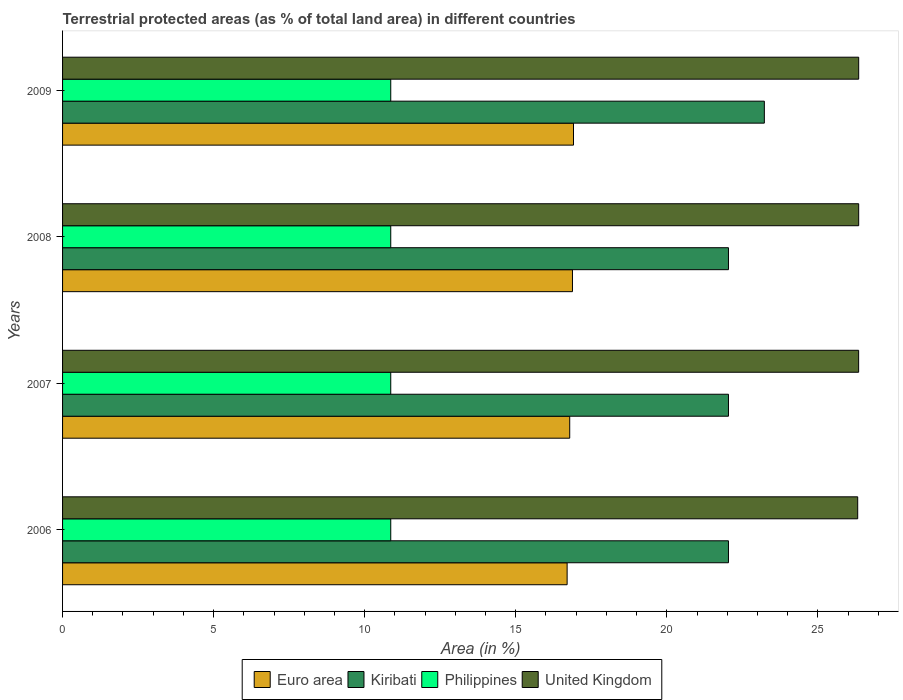Are the number of bars on each tick of the Y-axis equal?
Provide a short and direct response. Yes. How many bars are there on the 3rd tick from the top?
Offer a very short reply. 4. What is the label of the 1st group of bars from the top?
Your answer should be compact. 2009. What is the percentage of terrestrial protected land in Euro area in 2009?
Your response must be concise. 16.91. Across all years, what is the maximum percentage of terrestrial protected land in Philippines?
Your answer should be very brief. 10.86. Across all years, what is the minimum percentage of terrestrial protected land in Euro area?
Ensure brevity in your answer.  16.7. In which year was the percentage of terrestrial protected land in United Kingdom maximum?
Offer a very short reply. 2009. What is the total percentage of terrestrial protected land in Euro area in the graph?
Offer a terse response. 67.28. What is the difference between the percentage of terrestrial protected land in United Kingdom in 2007 and that in 2009?
Your response must be concise. -0. What is the difference between the percentage of terrestrial protected land in Euro area in 2009 and the percentage of terrestrial protected land in Philippines in 2008?
Your answer should be compact. 6.05. What is the average percentage of terrestrial protected land in Kiribati per year?
Give a very brief answer. 22.34. In the year 2006, what is the difference between the percentage of terrestrial protected land in United Kingdom and percentage of terrestrial protected land in Kiribati?
Ensure brevity in your answer.  4.28. In how many years, is the percentage of terrestrial protected land in Philippines greater than 24 %?
Provide a succinct answer. 0. What is the ratio of the percentage of terrestrial protected land in Philippines in 2007 to that in 2009?
Your answer should be very brief. 1. Is the difference between the percentage of terrestrial protected land in United Kingdom in 2006 and 2008 greater than the difference between the percentage of terrestrial protected land in Kiribati in 2006 and 2008?
Ensure brevity in your answer.  No. What is the difference between the highest and the second highest percentage of terrestrial protected land in Euro area?
Offer a terse response. 0.03. What is the difference between the highest and the lowest percentage of terrestrial protected land in United Kingdom?
Your answer should be very brief. 0.03. In how many years, is the percentage of terrestrial protected land in United Kingdom greater than the average percentage of terrestrial protected land in United Kingdom taken over all years?
Offer a terse response. 3. Is the sum of the percentage of terrestrial protected land in Kiribati in 2007 and 2009 greater than the maximum percentage of terrestrial protected land in Philippines across all years?
Give a very brief answer. Yes. What does the 2nd bar from the top in 2009 represents?
Provide a succinct answer. Philippines. What does the 1st bar from the bottom in 2006 represents?
Ensure brevity in your answer.  Euro area. How many years are there in the graph?
Give a very brief answer. 4. Are the values on the major ticks of X-axis written in scientific E-notation?
Keep it short and to the point. No. How many legend labels are there?
Keep it short and to the point. 4. What is the title of the graph?
Your response must be concise. Terrestrial protected areas (as % of total land area) in different countries. Does "Sri Lanka" appear as one of the legend labels in the graph?
Offer a terse response. No. What is the label or title of the X-axis?
Make the answer very short. Area (in %). What is the label or title of the Y-axis?
Provide a succinct answer. Years. What is the Area (in %) of Euro area in 2006?
Your answer should be very brief. 16.7. What is the Area (in %) of Kiribati in 2006?
Give a very brief answer. 22.04. What is the Area (in %) in Philippines in 2006?
Ensure brevity in your answer.  10.86. What is the Area (in %) in United Kingdom in 2006?
Provide a succinct answer. 26.32. What is the Area (in %) of Euro area in 2007?
Make the answer very short. 16.79. What is the Area (in %) in Kiribati in 2007?
Offer a terse response. 22.04. What is the Area (in %) in Philippines in 2007?
Offer a terse response. 10.86. What is the Area (in %) in United Kingdom in 2007?
Offer a terse response. 26.35. What is the Area (in %) in Euro area in 2008?
Keep it short and to the point. 16.88. What is the Area (in %) of Kiribati in 2008?
Give a very brief answer. 22.04. What is the Area (in %) in Philippines in 2008?
Provide a short and direct response. 10.86. What is the Area (in %) in United Kingdom in 2008?
Keep it short and to the point. 26.35. What is the Area (in %) of Euro area in 2009?
Make the answer very short. 16.91. What is the Area (in %) of Kiribati in 2009?
Offer a very short reply. 23.23. What is the Area (in %) in Philippines in 2009?
Your answer should be very brief. 10.86. What is the Area (in %) of United Kingdom in 2009?
Keep it short and to the point. 26.35. Across all years, what is the maximum Area (in %) of Euro area?
Your response must be concise. 16.91. Across all years, what is the maximum Area (in %) of Kiribati?
Provide a succinct answer. 23.23. Across all years, what is the maximum Area (in %) of Philippines?
Provide a succinct answer. 10.86. Across all years, what is the maximum Area (in %) in United Kingdom?
Provide a short and direct response. 26.35. Across all years, what is the minimum Area (in %) of Euro area?
Ensure brevity in your answer.  16.7. Across all years, what is the minimum Area (in %) in Kiribati?
Your answer should be compact. 22.04. Across all years, what is the minimum Area (in %) of Philippines?
Your answer should be very brief. 10.86. Across all years, what is the minimum Area (in %) in United Kingdom?
Make the answer very short. 26.32. What is the total Area (in %) of Euro area in the graph?
Give a very brief answer. 67.28. What is the total Area (in %) of Kiribati in the graph?
Provide a short and direct response. 89.35. What is the total Area (in %) of Philippines in the graph?
Offer a very short reply. 43.45. What is the total Area (in %) of United Kingdom in the graph?
Provide a succinct answer. 105.37. What is the difference between the Area (in %) of Euro area in 2006 and that in 2007?
Provide a succinct answer. -0.09. What is the difference between the Area (in %) of United Kingdom in 2006 and that in 2007?
Your answer should be very brief. -0.03. What is the difference between the Area (in %) of Euro area in 2006 and that in 2008?
Offer a terse response. -0.18. What is the difference between the Area (in %) in Kiribati in 2006 and that in 2008?
Your response must be concise. 0. What is the difference between the Area (in %) of United Kingdom in 2006 and that in 2008?
Offer a terse response. -0.03. What is the difference between the Area (in %) of Euro area in 2006 and that in 2009?
Your answer should be compact. -0.21. What is the difference between the Area (in %) in Kiribati in 2006 and that in 2009?
Make the answer very short. -1.19. What is the difference between the Area (in %) of Philippines in 2006 and that in 2009?
Your response must be concise. 0. What is the difference between the Area (in %) of United Kingdom in 2006 and that in 2009?
Your answer should be very brief. -0.03. What is the difference between the Area (in %) in Euro area in 2007 and that in 2008?
Your answer should be compact. -0.09. What is the difference between the Area (in %) in Kiribati in 2007 and that in 2008?
Keep it short and to the point. 0. What is the difference between the Area (in %) of Philippines in 2007 and that in 2008?
Your answer should be very brief. 0. What is the difference between the Area (in %) in United Kingdom in 2007 and that in 2008?
Offer a very short reply. -0. What is the difference between the Area (in %) of Euro area in 2007 and that in 2009?
Give a very brief answer. -0.12. What is the difference between the Area (in %) of Kiribati in 2007 and that in 2009?
Provide a succinct answer. -1.19. What is the difference between the Area (in %) of United Kingdom in 2007 and that in 2009?
Your answer should be compact. -0. What is the difference between the Area (in %) of Euro area in 2008 and that in 2009?
Provide a short and direct response. -0.03. What is the difference between the Area (in %) of Kiribati in 2008 and that in 2009?
Offer a very short reply. -1.19. What is the difference between the Area (in %) in Euro area in 2006 and the Area (in %) in Kiribati in 2007?
Give a very brief answer. -5.34. What is the difference between the Area (in %) of Euro area in 2006 and the Area (in %) of Philippines in 2007?
Provide a short and direct response. 5.84. What is the difference between the Area (in %) of Euro area in 2006 and the Area (in %) of United Kingdom in 2007?
Keep it short and to the point. -9.65. What is the difference between the Area (in %) in Kiribati in 2006 and the Area (in %) in Philippines in 2007?
Your response must be concise. 11.18. What is the difference between the Area (in %) in Kiribati in 2006 and the Area (in %) in United Kingdom in 2007?
Make the answer very short. -4.31. What is the difference between the Area (in %) in Philippines in 2006 and the Area (in %) in United Kingdom in 2007?
Provide a succinct answer. -15.49. What is the difference between the Area (in %) in Euro area in 2006 and the Area (in %) in Kiribati in 2008?
Make the answer very short. -5.34. What is the difference between the Area (in %) of Euro area in 2006 and the Area (in %) of Philippines in 2008?
Provide a succinct answer. 5.84. What is the difference between the Area (in %) in Euro area in 2006 and the Area (in %) in United Kingdom in 2008?
Give a very brief answer. -9.65. What is the difference between the Area (in %) in Kiribati in 2006 and the Area (in %) in Philippines in 2008?
Your answer should be very brief. 11.18. What is the difference between the Area (in %) in Kiribati in 2006 and the Area (in %) in United Kingdom in 2008?
Offer a very short reply. -4.31. What is the difference between the Area (in %) in Philippines in 2006 and the Area (in %) in United Kingdom in 2008?
Your answer should be compact. -15.49. What is the difference between the Area (in %) in Euro area in 2006 and the Area (in %) in Kiribati in 2009?
Offer a very short reply. -6.53. What is the difference between the Area (in %) of Euro area in 2006 and the Area (in %) of Philippines in 2009?
Keep it short and to the point. 5.84. What is the difference between the Area (in %) in Euro area in 2006 and the Area (in %) in United Kingdom in 2009?
Your answer should be compact. -9.65. What is the difference between the Area (in %) of Kiribati in 2006 and the Area (in %) of Philippines in 2009?
Provide a short and direct response. 11.18. What is the difference between the Area (in %) of Kiribati in 2006 and the Area (in %) of United Kingdom in 2009?
Your answer should be compact. -4.31. What is the difference between the Area (in %) in Philippines in 2006 and the Area (in %) in United Kingdom in 2009?
Make the answer very short. -15.49. What is the difference between the Area (in %) in Euro area in 2007 and the Area (in %) in Kiribati in 2008?
Your response must be concise. -5.25. What is the difference between the Area (in %) of Euro area in 2007 and the Area (in %) of Philippines in 2008?
Keep it short and to the point. 5.92. What is the difference between the Area (in %) in Euro area in 2007 and the Area (in %) in United Kingdom in 2008?
Provide a short and direct response. -9.56. What is the difference between the Area (in %) of Kiribati in 2007 and the Area (in %) of Philippines in 2008?
Offer a terse response. 11.18. What is the difference between the Area (in %) in Kiribati in 2007 and the Area (in %) in United Kingdom in 2008?
Provide a succinct answer. -4.31. What is the difference between the Area (in %) of Philippines in 2007 and the Area (in %) of United Kingdom in 2008?
Make the answer very short. -15.49. What is the difference between the Area (in %) in Euro area in 2007 and the Area (in %) in Kiribati in 2009?
Provide a succinct answer. -6.44. What is the difference between the Area (in %) in Euro area in 2007 and the Area (in %) in Philippines in 2009?
Ensure brevity in your answer.  5.92. What is the difference between the Area (in %) of Euro area in 2007 and the Area (in %) of United Kingdom in 2009?
Your answer should be very brief. -9.56. What is the difference between the Area (in %) in Kiribati in 2007 and the Area (in %) in Philippines in 2009?
Offer a very short reply. 11.18. What is the difference between the Area (in %) in Kiribati in 2007 and the Area (in %) in United Kingdom in 2009?
Your answer should be compact. -4.31. What is the difference between the Area (in %) of Philippines in 2007 and the Area (in %) of United Kingdom in 2009?
Ensure brevity in your answer.  -15.49. What is the difference between the Area (in %) of Euro area in 2008 and the Area (in %) of Kiribati in 2009?
Provide a short and direct response. -6.35. What is the difference between the Area (in %) of Euro area in 2008 and the Area (in %) of Philippines in 2009?
Provide a short and direct response. 6.02. What is the difference between the Area (in %) in Euro area in 2008 and the Area (in %) in United Kingdom in 2009?
Provide a short and direct response. -9.47. What is the difference between the Area (in %) of Kiribati in 2008 and the Area (in %) of Philippines in 2009?
Your response must be concise. 11.18. What is the difference between the Area (in %) in Kiribati in 2008 and the Area (in %) in United Kingdom in 2009?
Provide a short and direct response. -4.31. What is the difference between the Area (in %) in Philippines in 2008 and the Area (in %) in United Kingdom in 2009?
Ensure brevity in your answer.  -15.49. What is the average Area (in %) in Euro area per year?
Make the answer very short. 16.82. What is the average Area (in %) in Kiribati per year?
Your response must be concise. 22.34. What is the average Area (in %) of Philippines per year?
Offer a very short reply. 10.86. What is the average Area (in %) in United Kingdom per year?
Offer a very short reply. 26.34. In the year 2006, what is the difference between the Area (in %) in Euro area and Area (in %) in Kiribati?
Your answer should be compact. -5.34. In the year 2006, what is the difference between the Area (in %) in Euro area and Area (in %) in Philippines?
Your answer should be compact. 5.84. In the year 2006, what is the difference between the Area (in %) in Euro area and Area (in %) in United Kingdom?
Provide a succinct answer. -9.62. In the year 2006, what is the difference between the Area (in %) in Kiribati and Area (in %) in Philippines?
Your response must be concise. 11.18. In the year 2006, what is the difference between the Area (in %) of Kiribati and Area (in %) of United Kingdom?
Ensure brevity in your answer.  -4.28. In the year 2006, what is the difference between the Area (in %) of Philippines and Area (in %) of United Kingdom?
Give a very brief answer. -15.46. In the year 2007, what is the difference between the Area (in %) of Euro area and Area (in %) of Kiribati?
Keep it short and to the point. -5.25. In the year 2007, what is the difference between the Area (in %) in Euro area and Area (in %) in Philippines?
Offer a very short reply. 5.92. In the year 2007, what is the difference between the Area (in %) in Euro area and Area (in %) in United Kingdom?
Your response must be concise. -9.56. In the year 2007, what is the difference between the Area (in %) of Kiribati and Area (in %) of Philippines?
Give a very brief answer. 11.18. In the year 2007, what is the difference between the Area (in %) in Kiribati and Area (in %) in United Kingdom?
Offer a very short reply. -4.31. In the year 2007, what is the difference between the Area (in %) of Philippines and Area (in %) of United Kingdom?
Provide a short and direct response. -15.49. In the year 2008, what is the difference between the Area (in %) of Euro area and Area (in %) of Kiribati?
Ensure brevity in your answer.  -5.16. In the year 2008, what is the difference between the Area (in %) in Euro area and Area (in %) in Philippines?
Offer a very short reply. 6.02. In the year 2008, what is the difference between the Area (in %) in Euro area and Area (in %) in United Kingdom?
Your response must be concise. -9.47. In the year 2008, what is the difference between the Area (in %) of Kiribati and Area (in %) of Philippines?
Your response must be concise. 11.18. In the year 2008, what is the difference between the Area (in %) of Kiribati and Area (in %) of United Kingdom?
Provide a short and direct response. -4.31. In the year 2008, what is the difference between the Area (in %) of Philippines and Area (in %) of United Kingdom?
Offer a very short reply. -15.49. In the year 2009, what is the difference between the Area (in %) in Euro area and Area (in %) in Kiribati?
Offer a terse response. -6.32. In the year 2009, what is the difference between the Area (in %) in Euro area and Area (in %) in Philippines?
Offer a terse response. 6.05. In the year 2009, what is the difference between the Area (in %) of Euro area and Area (in %) of United Kingdom?
Your answer should be compact. -9.44. In the year 2009, what is the difference between the Area (in %) of Kiribati and Area (in %) of Philippines?
Provide a succinct answer. 12.37. In the year 2009, what is the difference between the Area (in %) in Kiribati and Area (in %) in United Kingdom?
Ensure brevity in your answer.  -3.12. In the year 2009, what is the difference between the Area (in %) of Philippines and Area (in %) of United Kingdom?
Keep it short and to the point. -15.49. What is the ratio of the Area (in %) in Kiribati in 2006 to that in 2007?
Provide a succinct answer. 1. What is the ratio of the Area (in %) in Philippines in 2006 to that in 2007?
Provide a succinct answer. 1. What is the ratio of the Area (in %) in United Kingdom in 2006 to that in 2007?
Offer a very short reply. 1. What is the ratio of the Area (in %) in Euro area in 2006 to that in 2008?
Your answer should be compact. 0.99. What is the ratio of the Area (in %) of Kiribati in 2006 to that in 2008?
Ensure brevity in your answer.  1. What is the ratio of the Area (in %) of Philippines in 2006 to that in 2008?
Your answer should be compact. 1. What is the ratio of the Area (in %) of United Kingdom in 2006 to that in 2008?
Make the answer very short. 1. What is the ratio of the Area (in %) of Euro area in 2006 to that in 2009?
Your answer should be very brief. 0.99. What is the ratio of the Area (in %) in Kiribati in 2006 to that in 2009?
Provide a succinct answer. 0.95. What is the ratio of the Area (in %) of Philippines in 2006 to that in 2009?
Keep it short and to the point. 1. What is the ratio of the Area (in %) of United Kingdom in 2006 to that in 2009?
Your answer should be very brief. 1. What is the ratio of the Area (in %) of Euro area in 2007 to that in 2008?
Provide a short and direct response. 0.99. What is the ratio of the Area (in %) of Philippines in 2007 to that in 2008?
Ensure brevity in your answer.  1. What is the ratio of the Area (in %) of Euro area in 2007 to that in 2009?
Your answer should be compact. 0.99. What is the ratio of the Area (in %) of Kiribati in 2007 to that in 2009?
Your answer should be compact. 0.95. What is the ratio of the Area (in %) in United Kingdom in 2007 to that in 2009?
Offer a very short reply. 1. What is the ratio of the Area (in %) of Euro area in 2008 to that in 2009?
Your answer should be very brief. 1. What is the ratio of the Area (in %) in Kiribati in 2008 to that in 2009?
Provide a short and direct response. 0.95. What is the ratio of the Area (in %) of United Kingdom in 2008 to that in 2009?
Offer a terse response. 1. What is the difference between the highest and the second highest Area (in %) in Euro area?
Provide a succinct answer. 0.03. What is the difference between the highest and the second highest Area (in %) of Kiribati?
Ensure brevity in your answer.  1.19. What is the difference between the highest and the second highest Area (in %) of Philippines?
Give a very brief answer. 0. What is the difference between the highest and the lowest Area (in %) of Euro area?
Provide a short and direct response. 0.21. What is the difference between the highest and the lowest Area (in %) in Kiribati?
Offer a very short reply. 1.19. What is the difference between the highest and the lowest Area (in %) of Philippines?
Give a very brief answer. 0. What is the difference between the highest and the lowest Area (in %) in United Kingdom?
Provide a succinct answer. 0.03. 